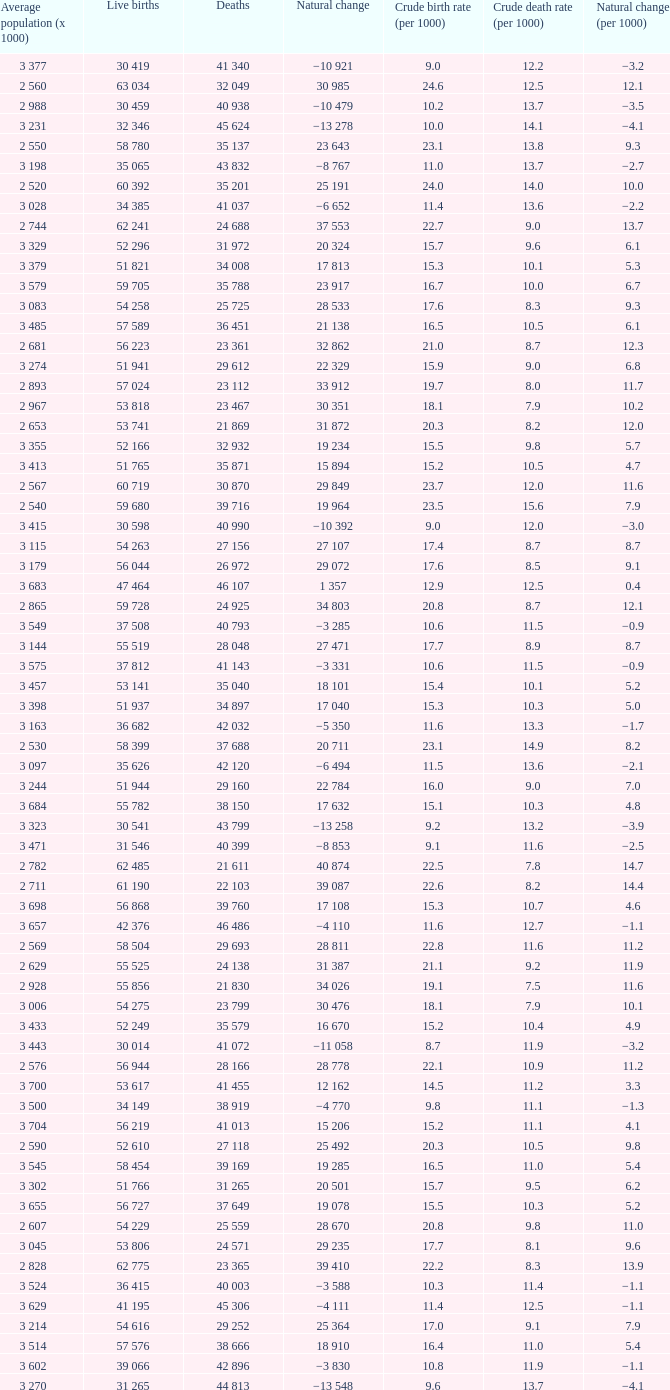Which Live births have a Natural change (per 1000) of 12.0? 53 741. 